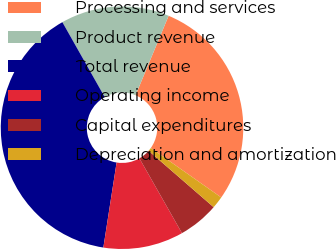<chart> <loc_0><loc_0><loc_500><loc_500><pie_chart><fcel>Processing and services<fcel>Product revenue<fcel>Total revenue<fcel>Operating income<fcel>Capital expenditures<fcel>Depreciation and amortization<nl><fcel>28.47%<fcel>14.46%<fcel>39.35%<fcel>10.69%<fcel>5.4%<fcel>1.62%<nl></chart> 